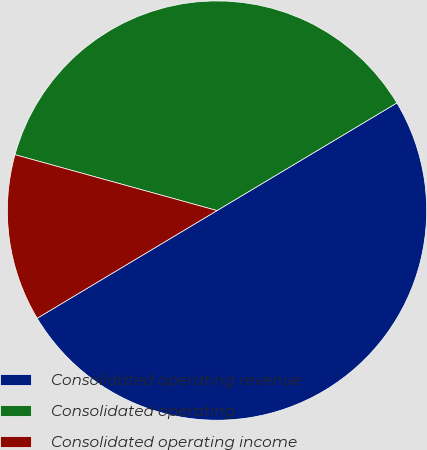Convert chart to OTSL. <chart><loc_0><loc_0><loc_500><loc_500><pie_chart><fcel>Consolidated operating revenue<fcel>Consolidated operating<fcel>Consolidated operating income<nl><fcel>50.0%<fcel>37.12%<fcel>12.88%<nl></chart> 